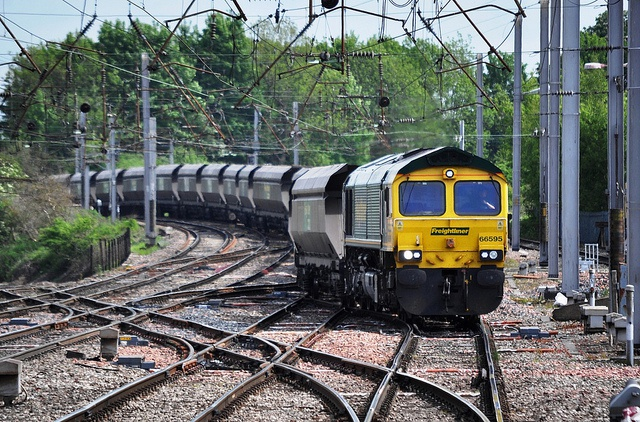Describe the objects in this image and their specific colors. I can see a train in lightblue, black, gray, darkgray, and orange tones in this image. 